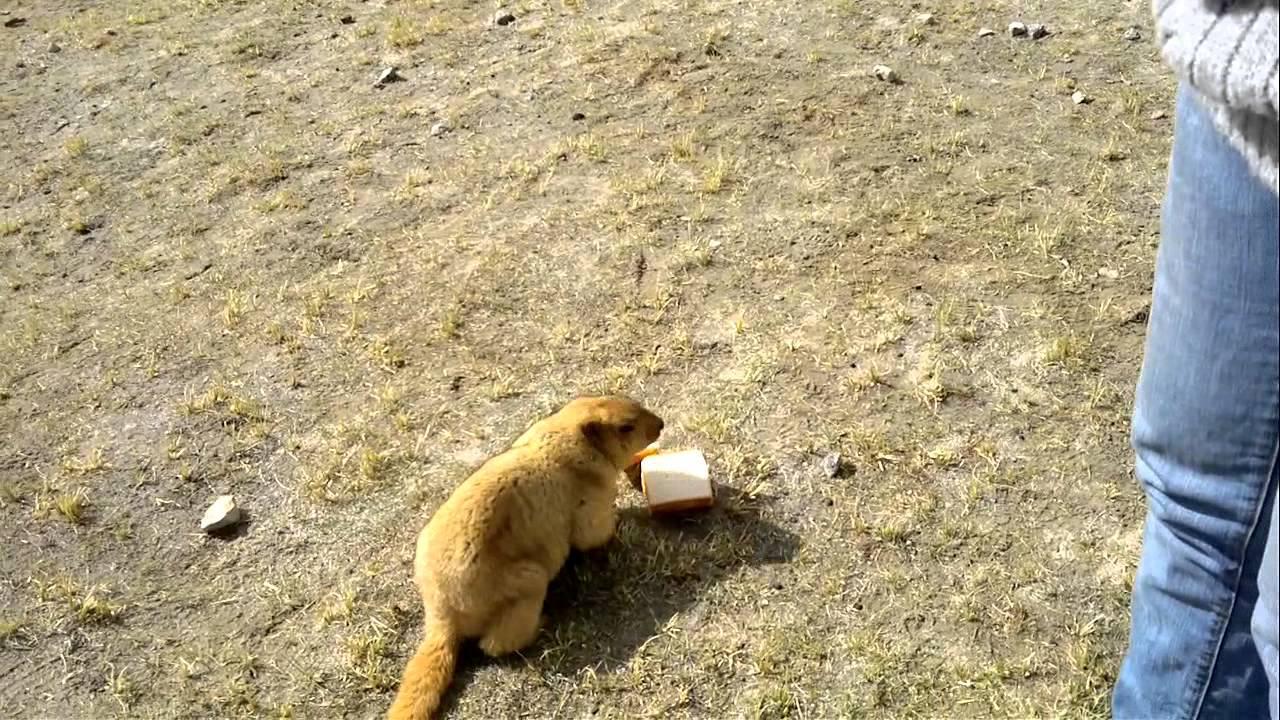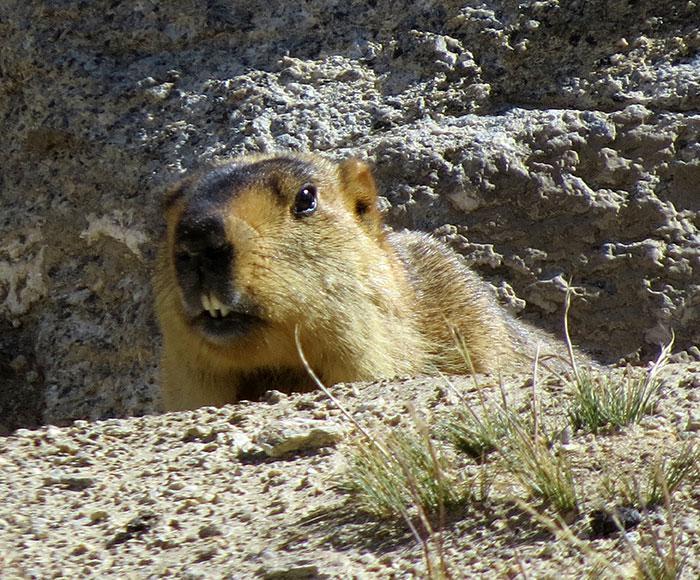The first image is the image on the left, the second image is the image on the right. Given the left and right images, does the statement "a single gopher is standing on hind legs with it's arms down" hold true? Answer yes or no. No. 